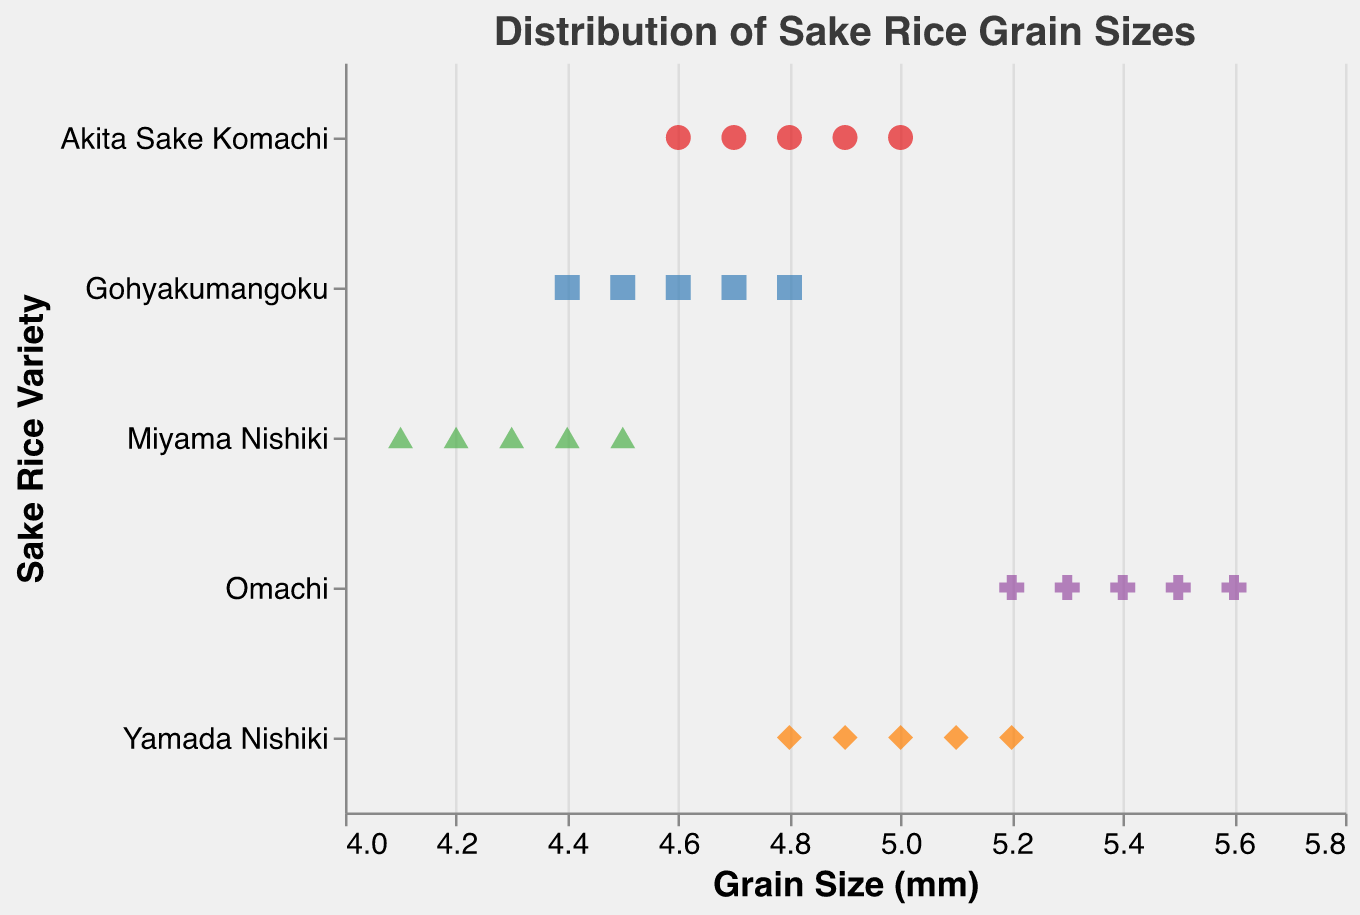What is the title of the figure? The title is located at the top of the figure and describes the overall content being visualized.
Answer: Distribution of Sake Rice Grain Sizes Which sake rice variety has the smallest grain size? Locate the smallest grain size value on the x-axis and identify the variety associated with that data point.
Answer: Miyama Nishiki Which sake rice variety has the largest grain size? Locate the largest grain size value on the x-axis and identify the variety associated with that data point.
Answer: Omachi How many sake rice varieties are represented in the figure? Count the distinct values on the y-axis, which represents different sake rice varieties.
Answer: 5 What is the range of grain sizes for the Yamada Nishiki variety? Identify the smallest and largest grain size values for Yamada Nishiki by looking at the points corresponding to this variety on the x-axis.
Answer: 4.8 to 5.2 mm What is the average grain size of the Omachi variety? Add the grain size values for Omachi and divide by the number of data points (5.3 + 5.5 + 5.2 + 5.4 + 5.6). The total is 27.0, and dividing by 5 data points gives 27.0/5.
Answer: 5.4 mm Which variety has the most consistent grain size, based on the visual spread of data points? Observing the spread of points horizontally for each variety, identify the one with the smallest range between the minimum and maximum grain sizes.
Answer: Miyama Nishiki How does the grain size of Akita Sake Komachi compare to that of Gohyakumangoku? Compare the range of grain sizes for both varieties. Akita Sake Komachi ranges from 4.6 to 5.0, while Gohyakumangoku ranges from 4.4 to 4.8.
Answer: Akita Sake Komachi generally has larger grain sizes What is the median grain size of the Gohyakumangoku variety? Arrange the grain sizes in ascending order: 4.4, 4.5, 4.6, 4.7, 4.8. The median is the middle value.
Answer: 4.6 mm Which variety has the widest range of grain sizes? Determine the difference between the maximum and minimum grain sizes for each variety and identify the variety with the largest difference.
Answer: Omachi 